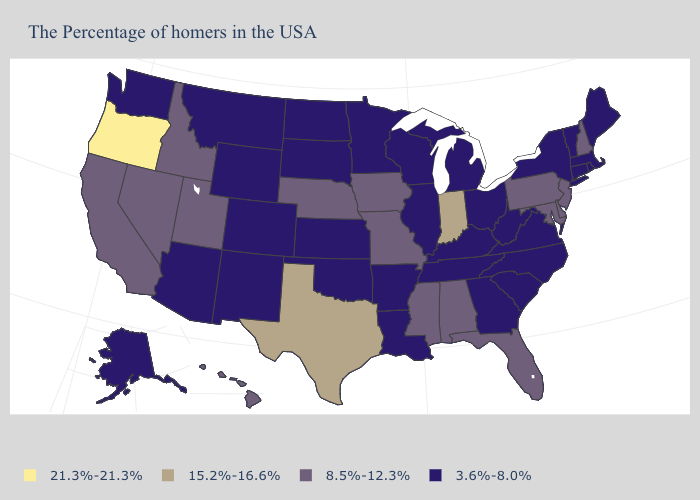What is the value of Connecticut?
Answer briefly. 3.6%-8.0%. What is the lowest value in the South?
Concise answer only. 3.6%-8.0%. Name the states that have a value in the range 3.6%-8.0%?
Keep it brief. Maine, Massachusetts, Rhode Island, Vermont, Connecticut, New York, Virginia, North Carolina, South Carolina, West Virginia, Ohio, Georgia, Michigan, Kentucky, Tennessee, Wisconsin, Illinois, Louisiana, Arkansas, Minnesota, Kansas, Oklahoma, South Dakota, North Dakota, Wyoming, Colorado, New Mexico, Montana, Arizona, Washington, Alaska. Among the states that border Washington , which have the highest value?
Answer briefly. Oregon. Does Ohio have a lower value than Delaware?
Quick response, please. Yes. Which states have the highest value in the USA?
Answer briefly. Oregon. What is the value of Delaware?
Quick response, please. 8.5%-12.3%. What is the lowest value in the Northeast?
Quick response, please. 3.6%-8.0%. Does Florida have a lower value than Indiana?
Keep it brief. Yes. Name the states that have a value in the range 15.2%-16.6%?
Write a very short answer. Indiana, Texas. Name the states that have a value in the range 15.2%-16.6%?
Write a very short answer. Indiana, Texas. Does Texas have a higher value than Indiana?
Short answer required. No. Does Utah have the highest value in the USA?
Short answer required. No. Does the map have missing data?
Quick response, please. No. What is the highest value in the MidWest ?
Give a very brief answer. 15.2%-16.6%. 